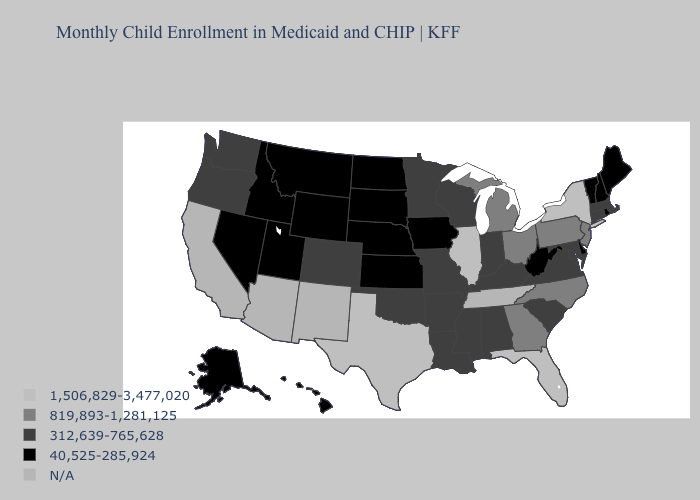What is the value of Missouri?
Keep it brief. 312,639-765,628. Does Utah have the lowest value in the USA?
Short answer required. Yes. Which states have the lowest value in the South?
Give a very brief answer. Delaware, West Virginia. What is the value of Ohio?
Quick response, please. 819,893-1,281,125. What is the lowest value in the MidWest?
Write a very short answer. 40,525-285,924. Among the states that border California , does Nevada have the lowest value?
Write a very short answer. Yes. What is the value of North Dakota?
Keep it brief. 40,525-285,924. Name the states that have a value in the range 312,639-765,628?
Answer briefly. Alabama, Arkansas, Colorado, Connecticut, Indiana, Kentucky, Louisiana, Maryland, Massachusetts, Minnesota, Mississippi, Missouri, Oklahoma, Oregon, South Carolina, Virginia, Washington, Wisconsin. How many symbols are there in the legend?
Short answer required. 5. Which states have the lowest value in the USA?
Concise answer only. Alaska, Delaware, Hawaii, Idaho, Iowa, Kansas, Maine, Montana, Nebraska, Nevada, New Hampshire, North Dakota, Rhode Island, South Dakota, Utah, Vermont, West Virginia, Wyoming. What is the value of Colorado?
Be succinct. 312,639-765,628. Among the states that border Delaware , which have the highest value?
Concise answer only. New Jersey, Pennsylvania. Name the states that have a value in the range 312,639-765,628?
Short answer required. Alabama, Arkansas, Colorado, Connecticut, Indiana, Kentucky, Louisiana, Maryland, Massachusetts, Minnesota, Mississippi, Missouri, Oklahoma, Oregon, South Carolina, Virginia, Washington, Wisconsin. Does Nevada have the highest value in the USA?
Short answer required. No. Which states have the highest value in the USA?
Concise answer only. Florida, Illinois, New York, Texas. 